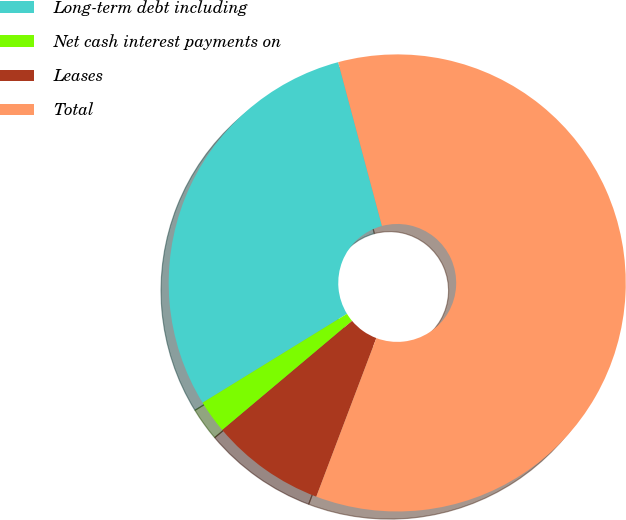Convert chart. <chart><loc_0><loc_0><loc_500><loc_500><pie_chart><fcel>Long-term debt including<fcel>Net cash interest payments on<fcel>Leases<fcel>Total<nl><fcel>29.62%<fcel>2.35%<fcel>8.11%<fcel>59.92%<nl></chart> 